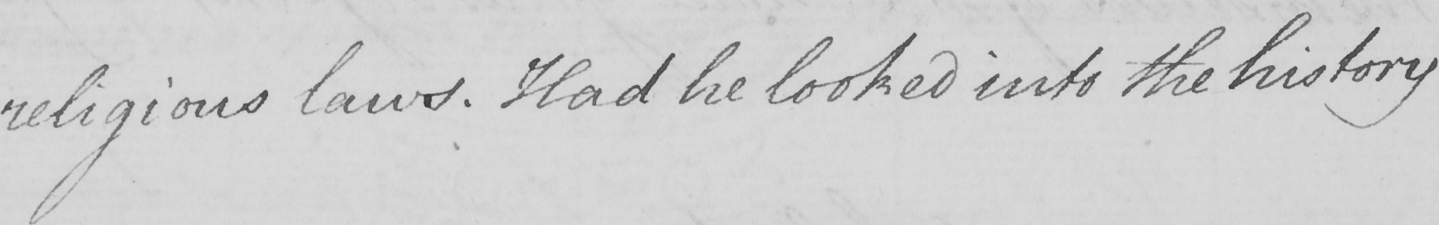What does this handwritten line say? religious laws . Had he looked into the history 